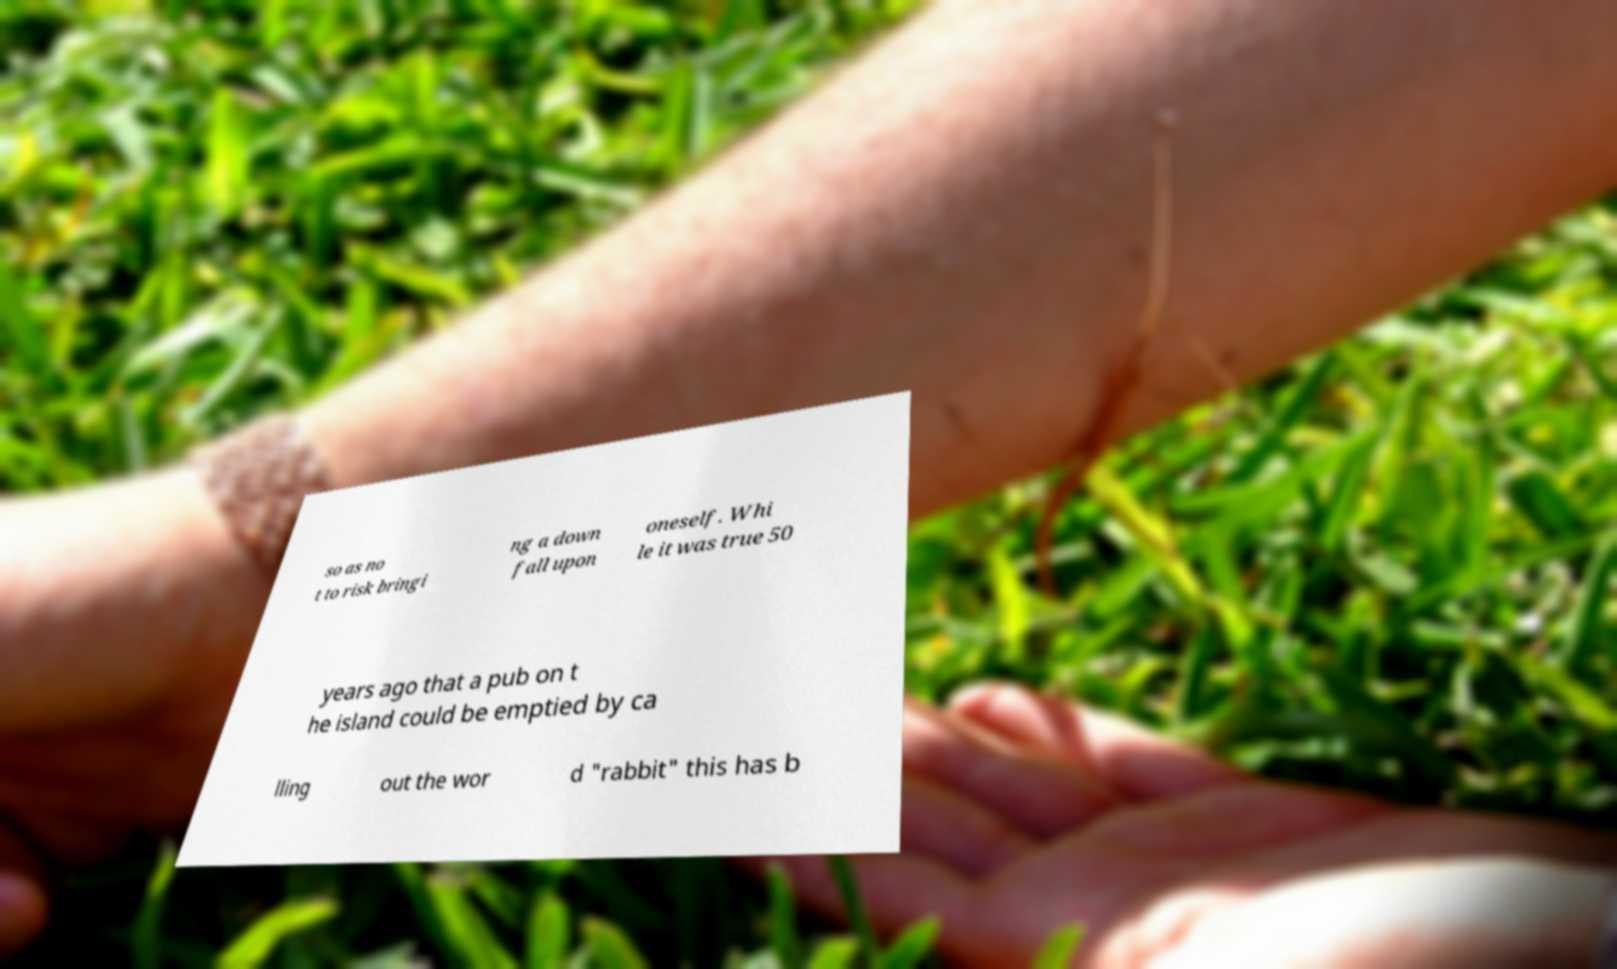What messages or text are displayed in this image? I need them in a readable, typed format. so as no t to risk bringi ng a down fall upon oneself. Whi le it was true 50 years ago that a pub on t he island could be emptied by ca lling out the wor d "rabbit" this has b 